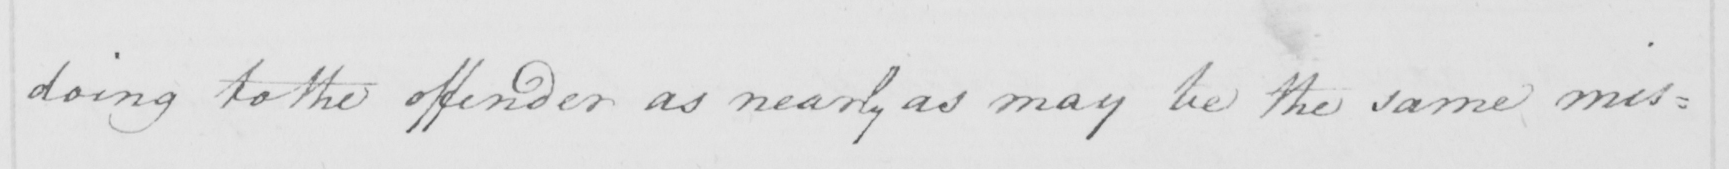What is written in this line of handwriting? doing to the offender as nearly as may be the same mis= 